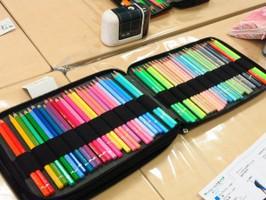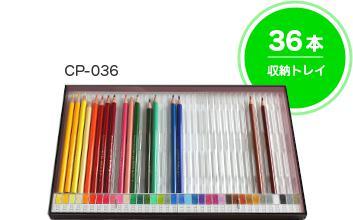The first image is the image on the left, the second image is the image on the right. For the images shown, is this caption "The pencils in the left image are supported with bands." true? Answer yes or no. Yes. 